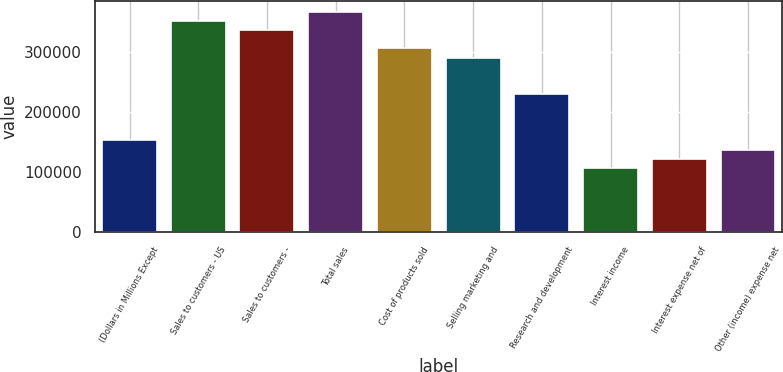<chart> <loc_0><loc_0><loc_500><loc_500><bar_chart><fcel>(Dollars in Millions Except<fcel>Sales to customers - US<fcel>Sales to customers -<fcel>Total sales<fcel>Cost of products sold<fcel>Selling marketing and<fcel>Research and development<fcel>Interest income<fcel>Interest expense net of<fcel>Other (income) expense net<nl><fcel>152954<fcel>351790<fcel>336495<fcel>367085<fcel>305905<fcel>290609<fcel>229429<fcel>107069<fcel>122364<fcel>137659<nl></chart> 